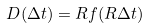<formula> <loc_0><loc_0><loc_500><loc_500>D ( \Delta t ) = R f ( R \Delta t )</formula> 